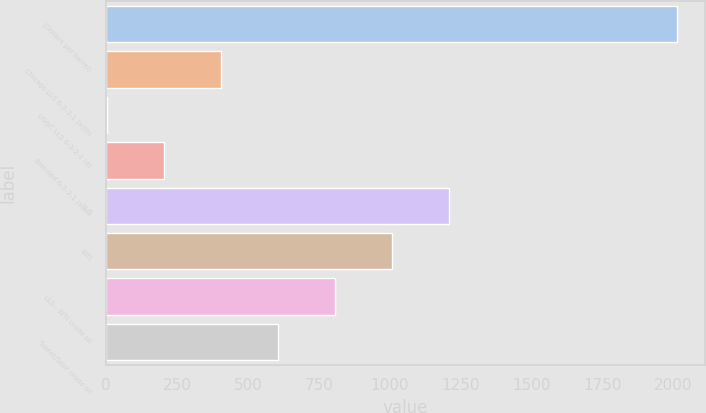Convert chart to OTSL. <chart><loc_0><loc_0><loc_500><loc_500><bar_chart><fcel>(Dollars per barrel)<fcel>Chicago LLS 6-3-2-1 (a)(b)<fcel>USGC LLS 6-3-2-1 (a)<fcel>Blended 6-3-2-1 (a)(c)<fcel>LLS<fcel>WTI<fcel>LLS - WTI crude oil<fcel>Sweet/Sour crude oil<nl><fcel>2011<fcel>404.48<fcel>2.84<fcel>203.66<fcel>1207.76<fcel>1006.94<fcel>806.12<fcel>605.3<nl></chart> 